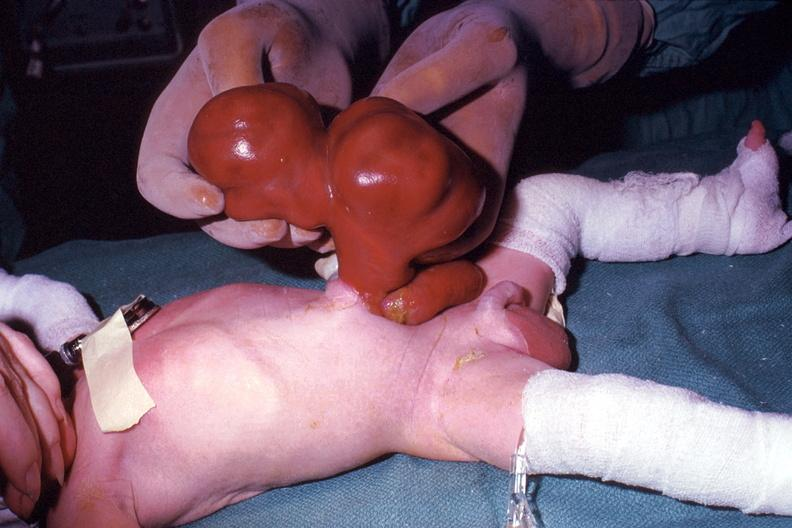what taken during life large lesion?
Answer the question using a single word or phrase. A photo 